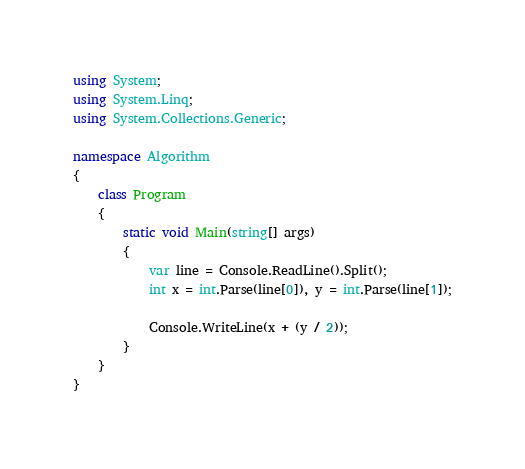Convert code to text. <code><loc_0><loc_0><loc_500><loc_500><_C#_>using System;
using System.Linq;
using System.Collections.Generic;

namespace Algorithm
{
    class Program
    {
        static void Main(string[] args)
        {
            var line = Console.ReadLine().Split();
            int x = int.Parse(line[0]), y = int.Parse(line[1]);

            Console.WriteLine(x + (y / 2));
        }
    }
}</code> 